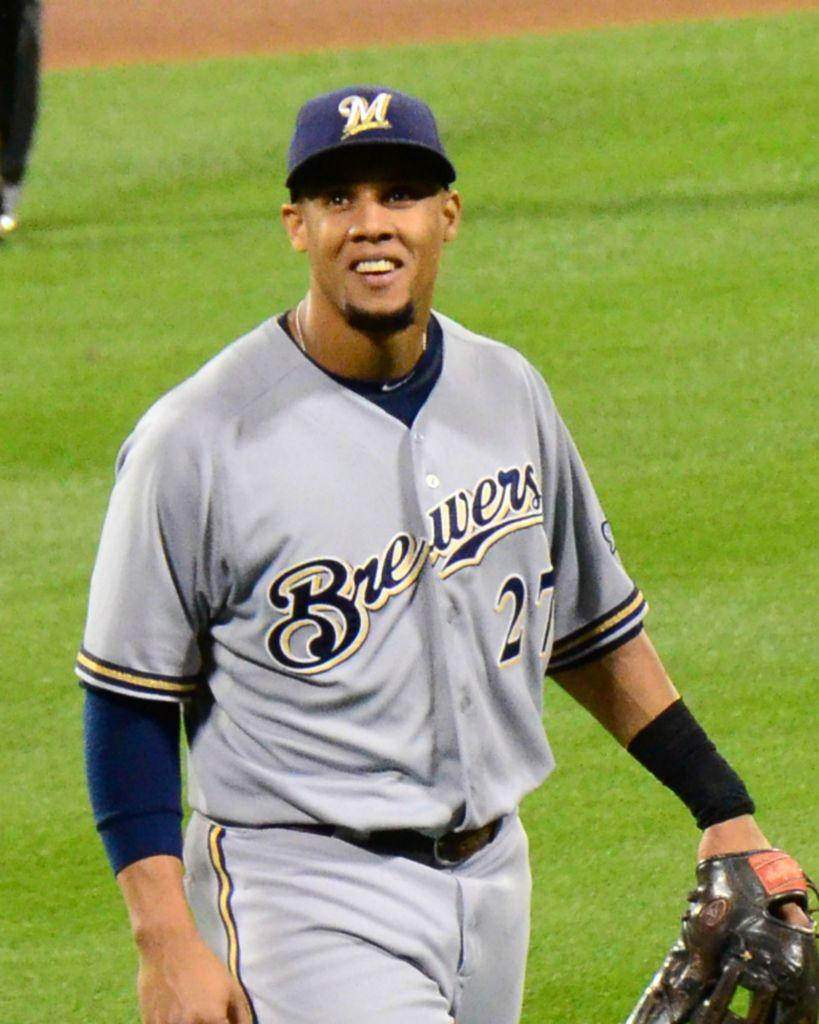What type of vegetation is present in the image? There is grass in the image. Can you describe the person in the image? The person in the image is wearing a blue cap and a grey jacket. What is the price of the horn in the image? There is no horn present in the image, so it is not possible to determine its price. 